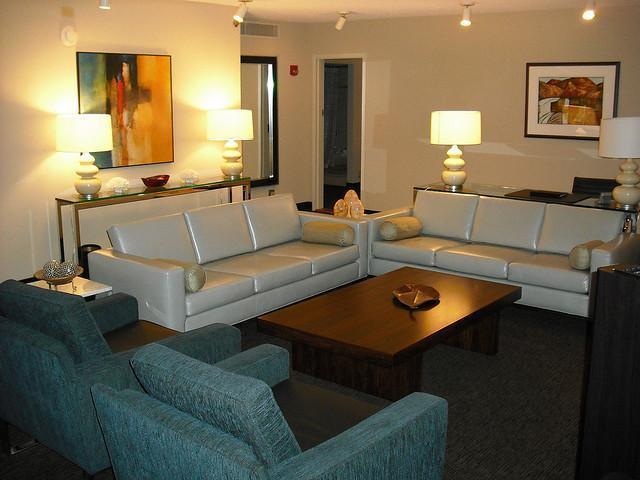How many sofas are in the room?
Give a very brief answer. 2. How many lamps are on?
Give a very brief answer. 3. How many pillows are pictured?
Give a very brief answer. 4. How many couches can you see?
Give a very brief answer. 2. How many chairs can you see?
Give a very brief answer. 2. 